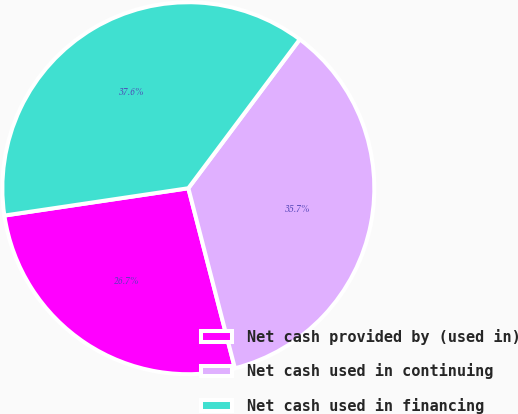<chart> <loc_0><loc_0><loc_500><loc_500><pie_chart><fcel>Net cash provided by (used in)<fcel>Net cash used in continuing<fcel>Net cash used in financing<nl><fcel>26.68%<fcel>35.74%<fcel>37.57%<nl></chart> 